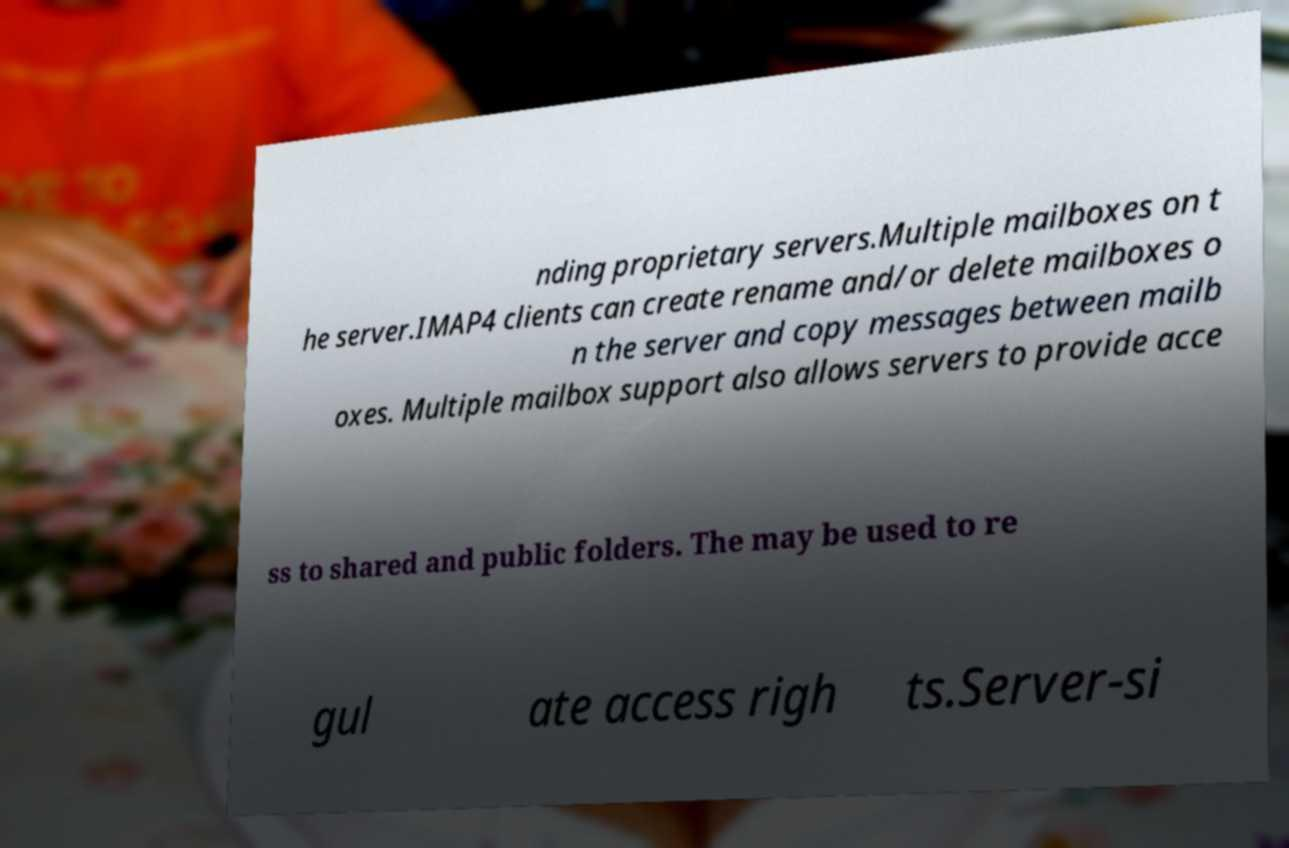For documentation purposes, I need the text within this image transcribed. Could you provide that? nding proprietary servers.Multiple mailboxes on t he server.IMAP4 clients can create rename and/or delete mailboxes o n the server and copy messages between mailb oxes. Multiple mailbox support also allows servers to provide acce ss to shared and public folders. The may be used to re gul ate access righ ts.Server-si 